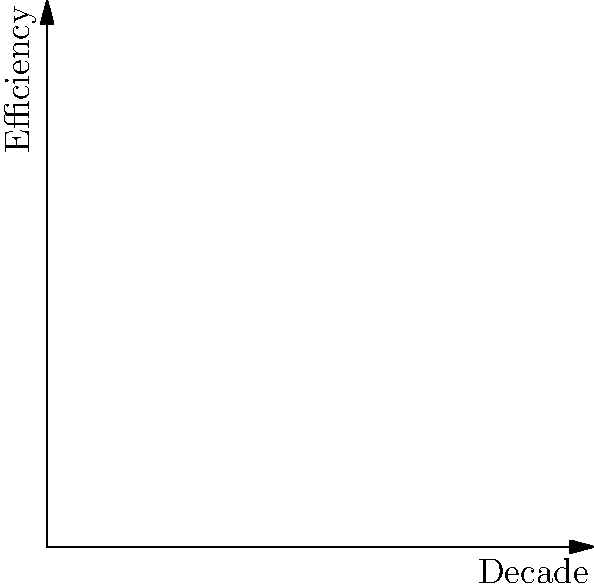Based on the graph showing the biomechanical efficiency of different football boot designs through the decades, which type of boot material consistently demonstrated the highest efficiency across all periods, and how might this have impacted the performance of East German players during international competitions? To answer this question, we need to analyze the graph and consider the historical context:

1. The graph shows three curves representing different boot materials: Leather, Synthetic, and Hybrid.

2. Examining the curves:
   - The red curve (Leather) shows consistent high efficiency but with some fluctuations.
   - The blue curve (Synthetic) starts lower but steadily increases over time.
   - The green curve (Hybrid) shows the highest overall efficiency across all decades.

3. The Hybrid material, represented by the green curve, consistently demonstrates the highest efficiency throughout the timeline.

4. Impact on East German players:
   - East Germany existed from 1949 to 1990, spanning several decades shown in the graph.
   - During this period, access to advanced Western technologies was often limited due to political restrictions.
   - The consistently high efficiency of Hybrid boots might not have been readily available to East German players.

5. Performance implications:
   - East German players likely had to rely more on traditional leather boots or early synthetic materials.
   - This could have put them at a slight disadvantage in terms of boot efficiency, especially in later years.
   - However, the difference in efficiency is relatively small, and other factors (like training and tactics) would have played more significant roles.

6. Historical context:
   - Despite potential technological disadvantages, East German football achieved notable successes, including winning the 1976 Olympic gold medal.
   - The limited access to cutting-edge boot technology might have encouraged East German players and coaches to focus more on technique and strategy.

In conclusion, while Hybrid boots showed the highest consistent efficiency, the impact on East German players' performance would have been minimal compared to other factors in football success.
Answer: Hybrid boots; minimal impact due to other dominant factors in football performance. 